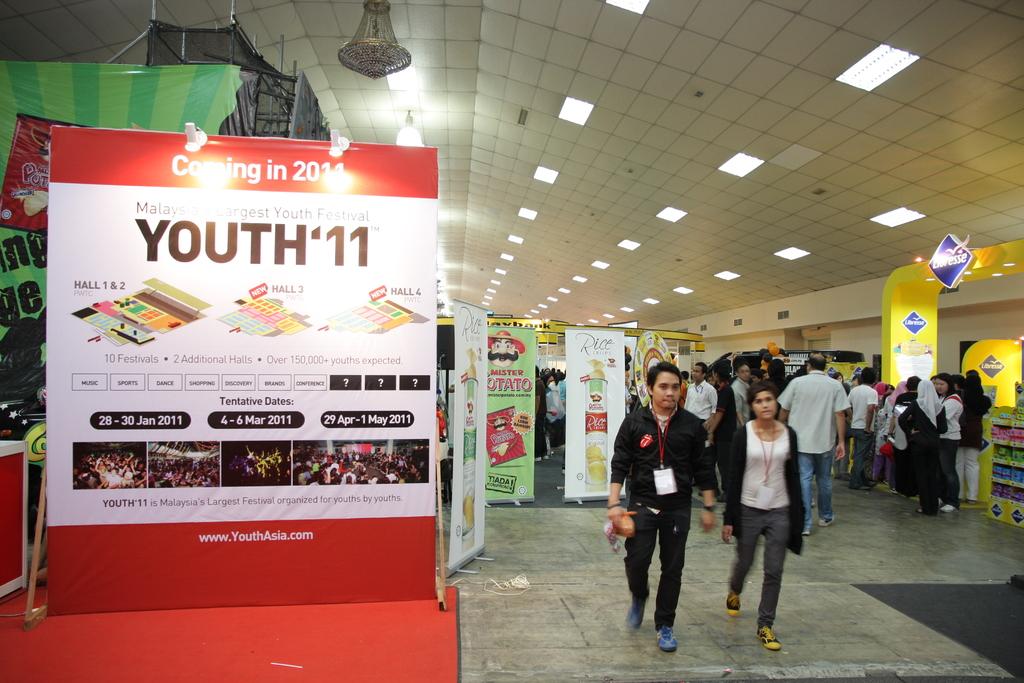When is it coming?
Your response must be concise. 2011. What year was this event?
Your answer should be very brief. 2011. 